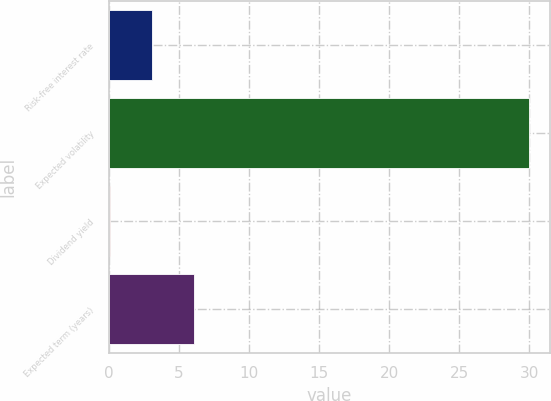Convert chart. <chart><loc_0><loc_0><loc_500><loc_500><bar_chart><fcel>Risk-free interest rate<fcel>Expected volatility<fcel>Dividend yield<fcel>Expected term (years)<nl><fcel>3.05<fcel>30<fcel>0.06<fcel>6.04<nl></chart> 